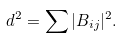Convert formula to latex. <formula><loc_0><loc_0><loc_500><loc_500>d ^ { 2 } = \sum | B _ { i j } | ^ { 2 } .</formula> 